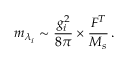Convert formula to latex. <formula><loc_0><loc_0><loc_500><loc_500>m _ { \lambda _ { i } } \sim \frac { g _ { i } ^ { 2 } } { 8 \pi } \times \frac { F ^ { T } } { M _ { s } } \, .</formula> 